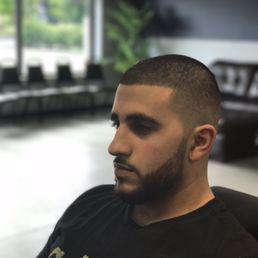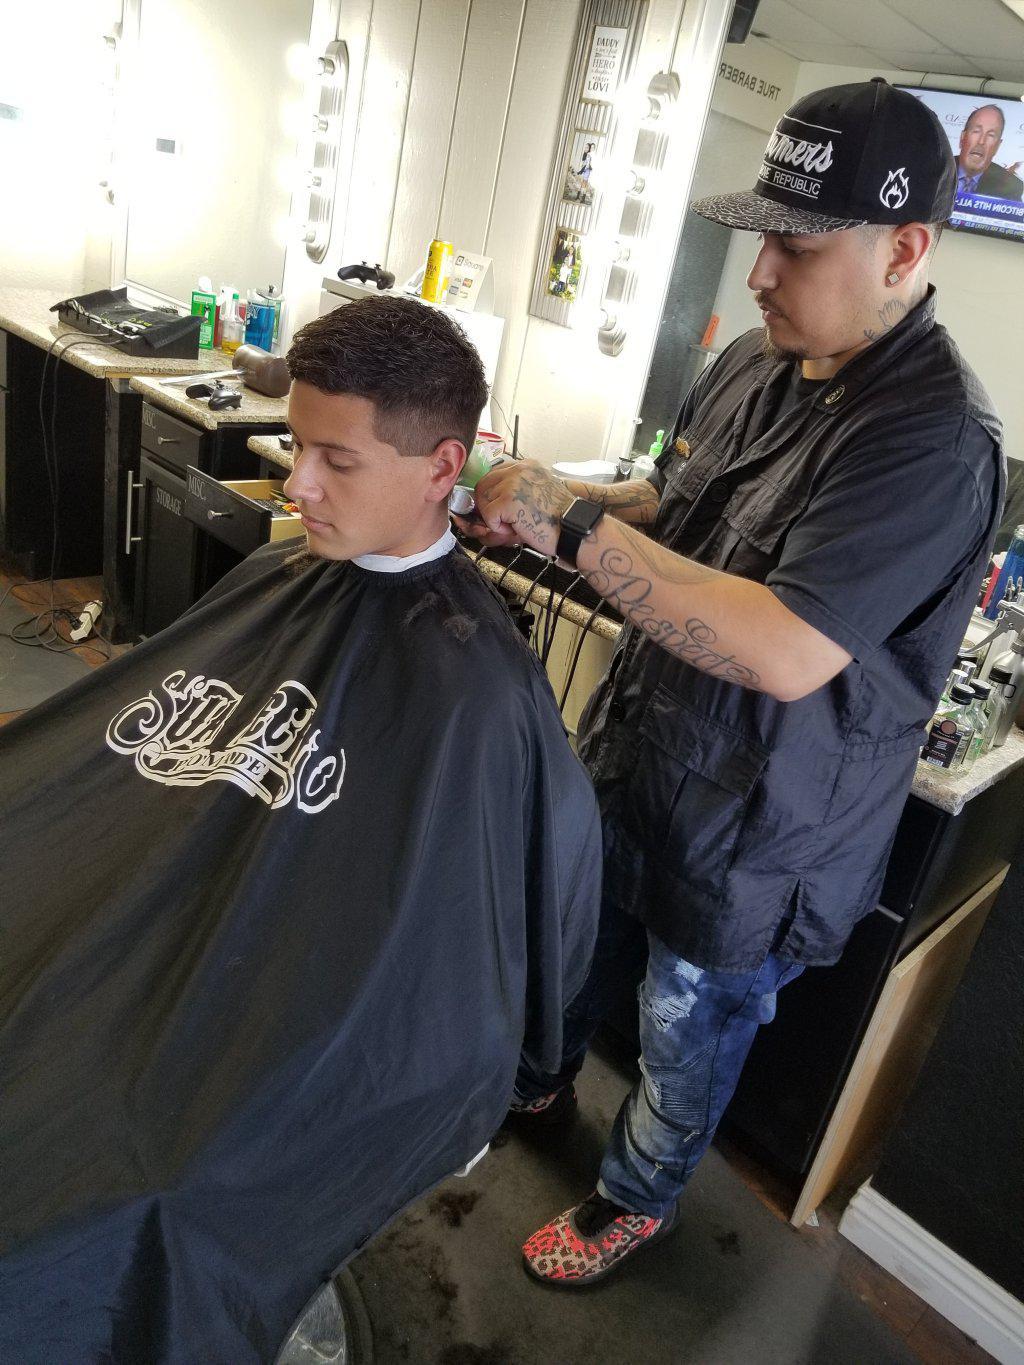The first image is the image on the left, the second image is the image on the right. Considering the images on both sides, is "A barber in a baseball cap is cutting a mans hair, the person getting their hair cut is wearing a protective cover to shield from the falling hair" valid? Answer yes or no. Yes. 